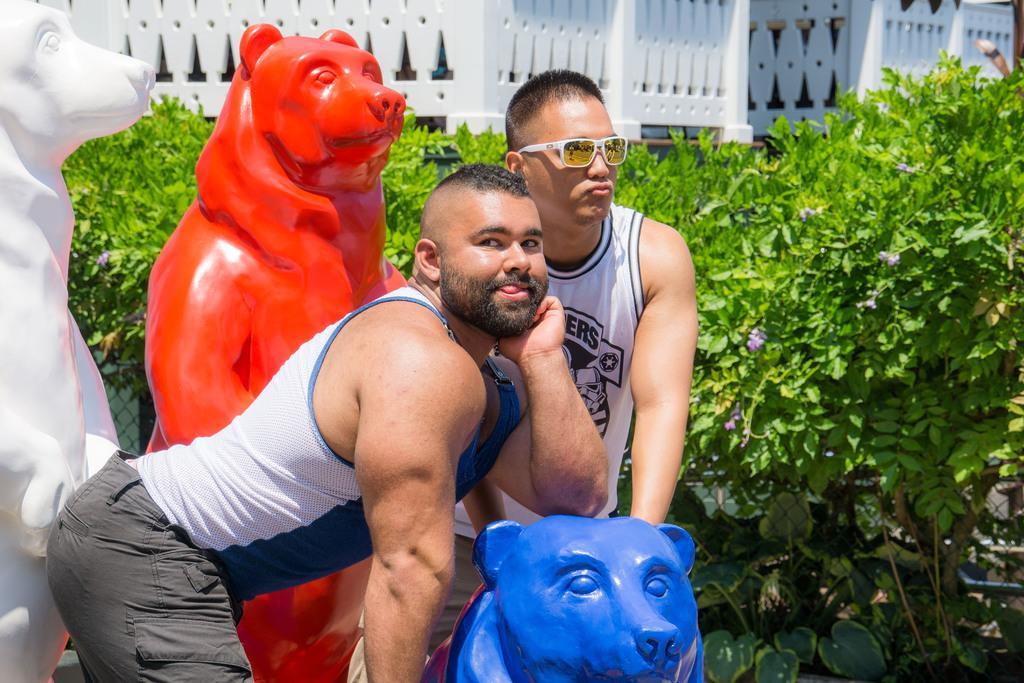In one or two sentences, can you explain what this image depicts? In this image these two persons standing in middle of this image and there are some sculptures of bears at left side of this image and there are some trees in the background and there are some buildings at top of this image. 